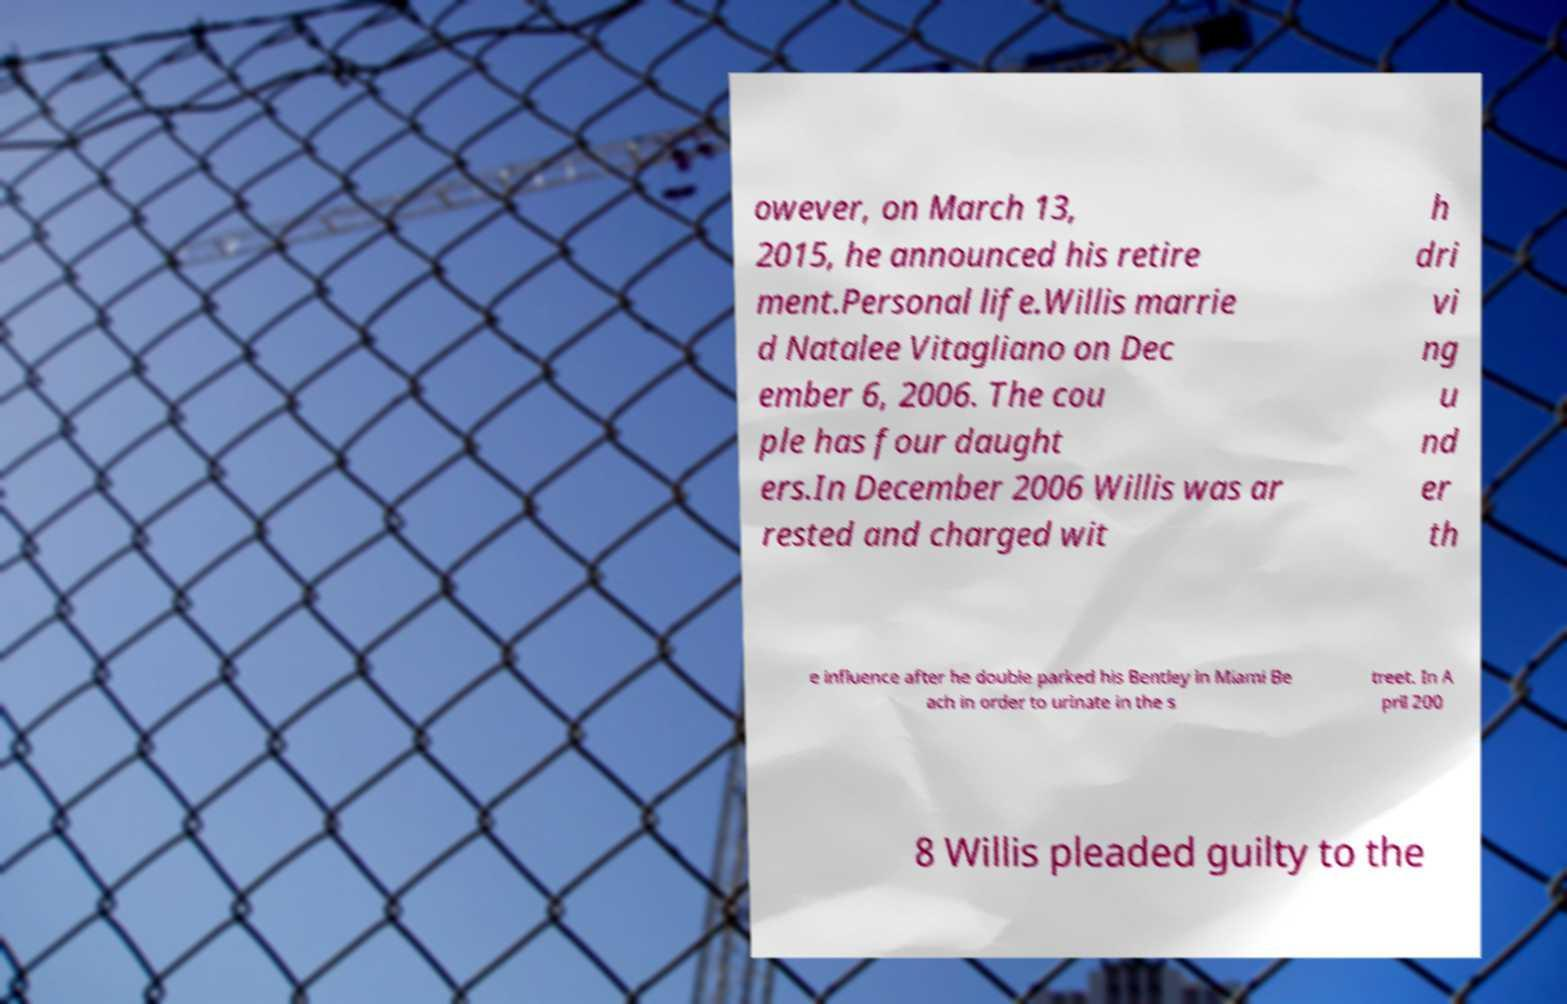There's text embedded in this image that I need extracted. Can you transcribe it verbatim? owever, on March 13, 2015, he announced his retire ment.Personal life.Willis marrie d Natalee Vitagliano on Dec ember 6, 2006. The cou ple has four daught ers.In December 2006 Willis was ar rested and charged wit h dri vi ng u nd er th e influence after he double parked his Bentley in Miami Be ach in order to urinate in the s treet. In A pril 200 8 Willis pleaded guilty to the 